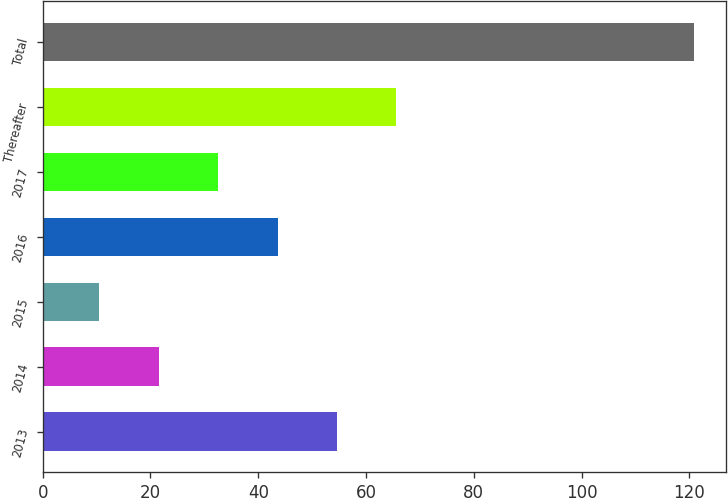Convert chart. <chart><loc_0><loc_0><loc_500><loc_500><bar_chart><fcel>2013<fcel>2014<fcel>2015<fcel>2016<fcel>2017<fcel>Thereafter<fcel>Total<nl><fcel>54.62<fcel>21.53<fcel>10.5<fcel>43.59<fcel>32.56<fcel>65.65<fcel>120.8<nl></chart> 